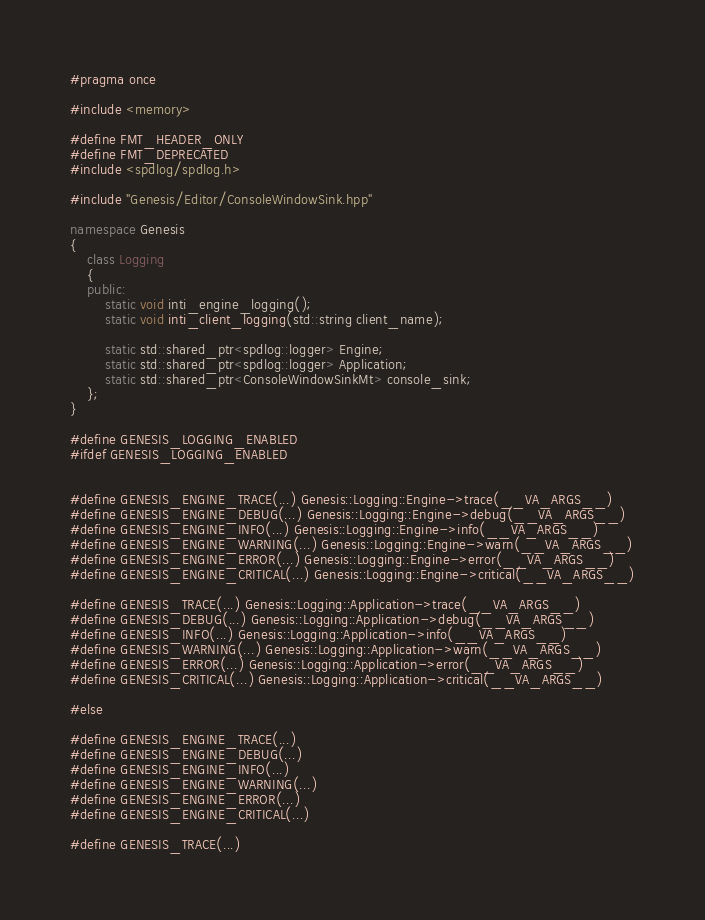Convert code to text. <code><loc_0><loc_0><loc_500><loc_500><_C++_>#pragma once

#include <memory>

#define FMT_HEADER_ONLY
#define FMT_DEPRECATED
#include <spdlog/spdlog.h>

#include "Genesis/Editor/ConsoleWindowSink.hpp"

namespace Genesis
{
	class Logging
	{
	public:
		static void inti_engine_logging();
		static void inti_client_logging(std::string client_name);

		static std::shared_ptr<spdlog::logger> Engine;
		static std::shared_ptr<spdlog::logger> Application;
		static std::shared_ptr<ConsoleWindowSinkMt> console_sink;
	};
}

#define GENESIS_LOGGING_ENABLED
#ifdef GENESIS_LOGGING_ENABLED


#define GENESIS_ENGINE_TRACE(...) Genesis::Logging::Engine->trace(__VA_ARGS__)
#define GENESIS_ENGINE_DEBUG(...) Genesis::Logging::Engine->debug(__VA_ARGS__)
#define GENESIS_ENGINE_INFO(...) Genesis::Logging::Engine->info(__VA_ARGS__)
#define GENESIS_ENGINE_WARNING(...) Genesis::Logging::Engine->warn(__VA_ARGS__)
#define GENESIS_ENGINE_ERROR(...) Genesis::Logging::Engine->error(__VA_ARGS__)
#define GENESIS_ENGINE_CRITICAL(...) Genesis::Logging::Engine->critical(__VA_ARGS__)

#define GENESIS_TRACE(...) Genesis::Logging::Application->trace(__VA_ARGS__)
#define GENESIS_DEBUG(...) Genesis::Logging::Application->debug(__VA_ARGS__)
#define GENESIS_INFO(...) Genesis::Logging::Application->info(__VA_ARGS__)
#define GENESIS_WARNING(...) Genesis::Logging::Application->warn(__VA_ARGS__)
#define GENESIS_ERROR(...) Genesis::Logging::Application->error(__VA_ARGS__)
#define GENESIS_CRITICAL(...) Genesis::Logging::Application->critical(__VA_ARGS__)

#else

#define GENESIS_ENGINE_TRACE(...)
#define GENESIS_ENGINE_DEBUG(...)
#define GENESIS_ENGINE_INFO(...)
#define GENESIS_ENGINE_WARNING(...)
#define GENESIS_ENGINE_ERROR(...)
#define GENESIS_ENGINE_CRITICAL(...)

#define GENESIS_TRACE(...)</code> 